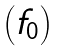<formula> <loc_0><loc_0><loc_500><loc_500>\begin{pmatrix} f _ { 0 } \end{pmatrix}</formula> 